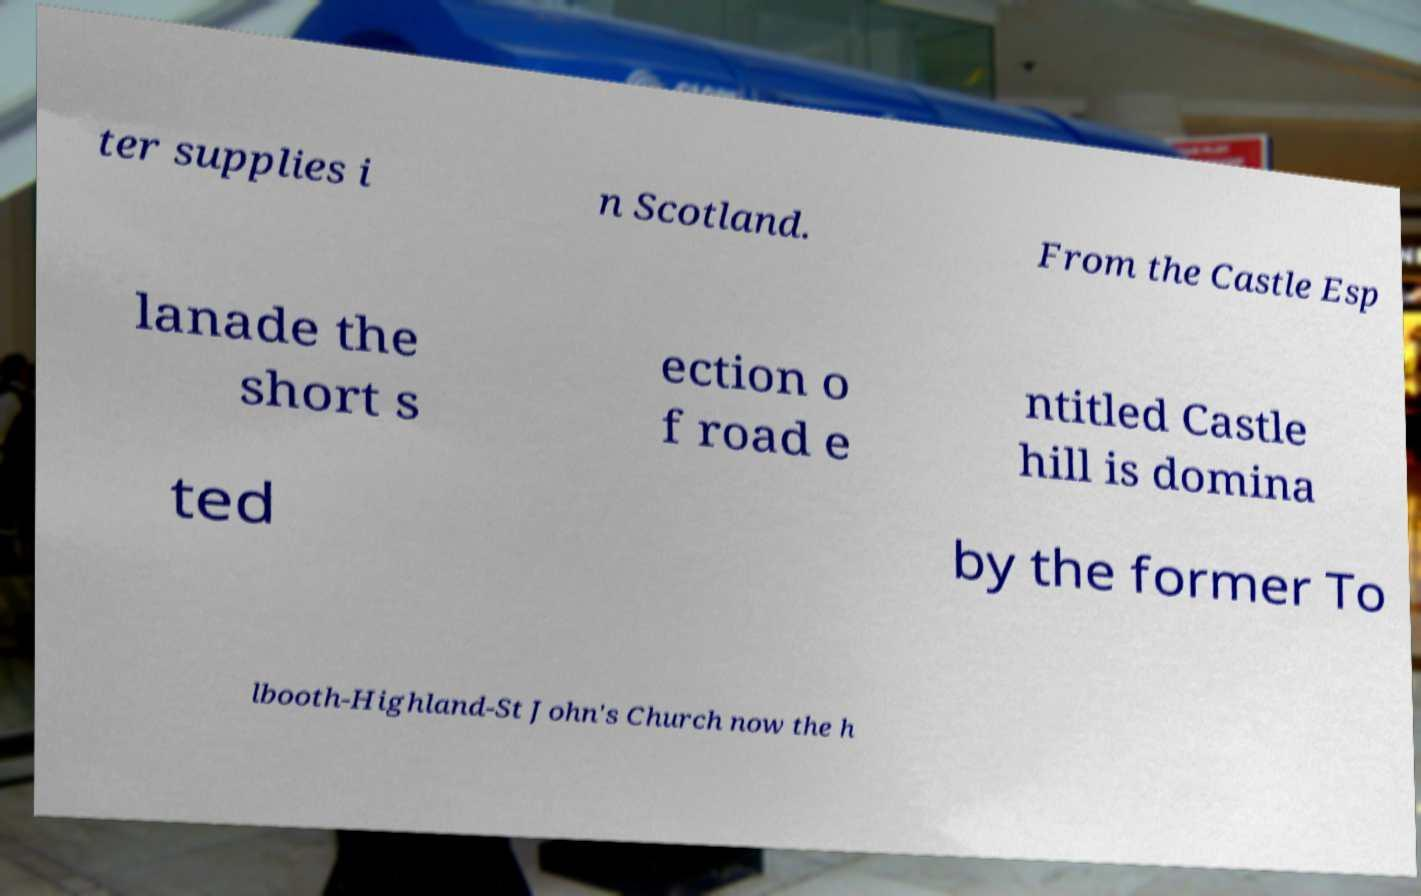For documentation purposes, I need the text within this image transcribed. Could you provide that? ter supplies i n Scotland. From the Castle Esp lanade the short s ection o f road e ntitled Castle hill is domina ted by the former To lbooth-Highland-St John's Church now the h 